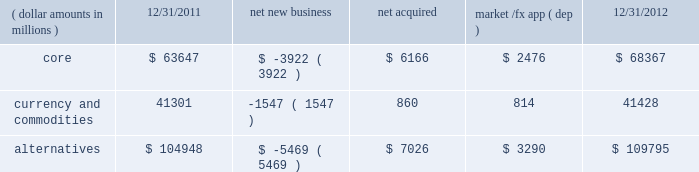Challenging investment environment with $ 15.0 billion , or 95% ( 95 % ) , of net inflows coming from institutional clients , with the remaining $ 0.8 billion , or 5% ( 5 % ) , generated by retail and hnw clients .
Defined contribution plans of institutional clients remained a significant driver of flows .
This client group added $ 13.1 billion of net new business in 2012 .
During the year , americas net inflows of $ 18.5 billion were partially offset by net outflows of $ 2.6 billion collectively from emea and asia-pacific clients .
The company 2019s multi-asset strategies include the following : 2022 asset allocation and balanced products represented 52% ( 52 % ) , or $ 140.2 billion , of multi-asset class aum at year-end , up $ 14.1 billion , with growth in aum driven by net new business of $ 1.6 billion and $ 12.4 billion in market and foreign exchange gains .
These strategies combine equity , fixed income and alternative components for investors seeking a tailored solution relative to a specific benchmark and within a risk budget .
In certain cases , these strategies seek to minimize downside risk through diversification , derivatives strategies and tactical asset allocation decisions .
2022 target date and target risk products ended the year at $ 69.9 billion , up $ 20.8 billion , or 42% ( 42 % ) , since december 31 , 2011 .
Growth in aum was driven by net new business of $ 14.5 billion , a year-over-year organic growth rate of 30% ( 30 % ) .
Institutional investors represented 90% ( 90 % ) of target date and target risk aum , with defined contribution plans accounting for over 80% ( 80 % ) of aum .
The remaining 10% ( 10 % ) of target date and target risk aum consisted of retail client investments .
Flows were driven by defined contribution investments in our lifepath and lifepath retirement income ae offerings , which are qualified investment options under the pension protection act of 2006 .
These products utilize a proprietary asset allocation model that seeks to balance risk and return over an investment horizon based on the investor 2019s expected retirement timing .
2022 fiduciary management services accounted for 22% ( 22 % ) , or $ 57.7 billion , of multi-asset aum at december 31 , 2012 and increased $ 7.7 billion during the year due to market and foreign exchange gains .
These are complex mandates in which pension plan sponsors retain blackrock to assume responsibility for some or all aspects of plan management .
These customized services require strong partnership with the clients 2019 investment staff and trustees in order to tailor investment strategies to meet client-specific risk budgets and return objectives .
Alternatives component changes in alternatives aum ( dollar amounts in millions ) 12/31/2011 net new business acquired market /fx app ( dep ) 12/31/2012 .
Alternatives aum totaled $ 109.8 billion at year-end 2012 , up $ 4.8 billion , or 5% ( 5 % ) , reflecting $ 3.3 billion in portfolio valuation gains and $ 7.0 billion in new assets related to the acquisitions of srpep , which deepened our alternatives footprint in the european and asian markets , and claymore .
Core alternative outflows of $ 3.9 billion were driven almost exclusively by return of capital to clients .
Currency net outflows of $ 5.0 billion were partially offset by net inflows of $ 3.5 billion into ishares commodity funds .
We continued to make significant investments in our alternatives platform as demonstrated by our acquisition of srpep , successful closes on the renewable power initiative and our build out of an alternatives retail platform , which now stands at nearly $ 10.0 billion in aum .
We believe that as alternatives become more conventional and investors adapt their asset allocation strategies to best meet their investment objectives , they will further increase their use of alternative investments to complement core holdings .
Institutional investors represented 69% ( 69 % ) , or $ 75.8 billion , of alternatives aum with retail and hnw investors comprising an additional 9% ( 9 % ) , or $ 9.7 billion , at year-end 2012 .
Ishares commodity products accounted for the remaining $ 24.3 billion , or 22% ( 22 % ) , of aum at year-end .
Alternative clients are geographically diversified with 56% ( 56 % ) , 26% ( 26 % ) , and 18% ( 18 % ) of clients located in the americas , emea and asia-pacific , respectively .
The blackrock alternative investors ( 201cbai 201d ) group coordinates our alternative investment efforts , including .
What is the percentage change in the balance of alternative assets from 2011 to 2012? 
Computations: ((109795 - 104948) / 104948)
Answer: 0.04618. 